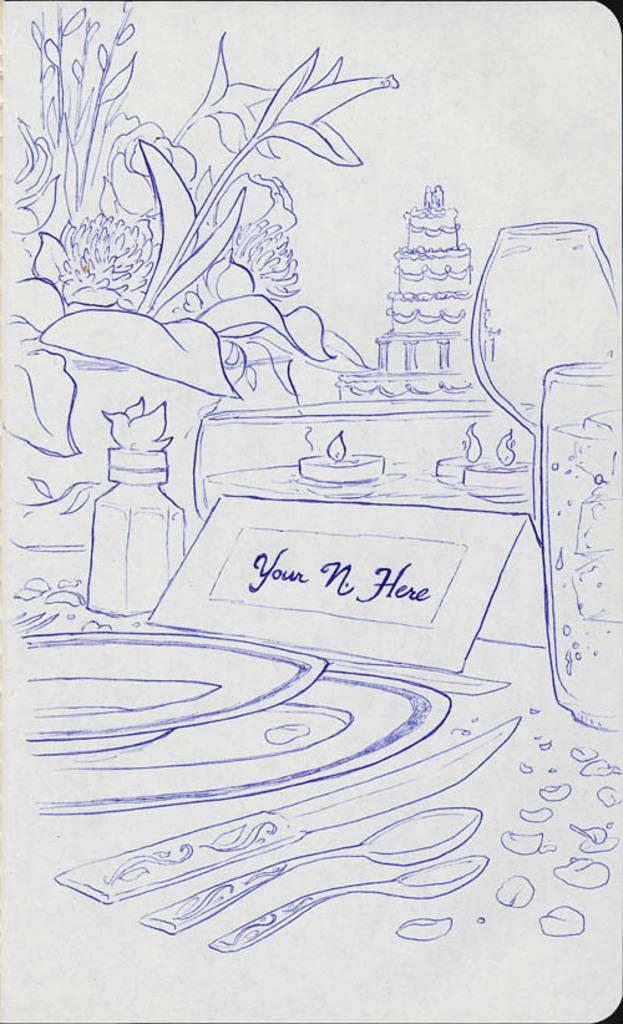What is the main subject of the drawing in the image? The main subject of the drawing in the image is a tree. What other objects are depicted in the drawing? There is a drawing of a cake, a glass, a plate, spoons, and a knife in the image. Are there any other objects drawn on the paper in the image? Yes, there are other objects drawn on the paper in the image. What type of club can be seen in the image? There is no club present in the image; it features a drawing of various objects, including a tree, cake, glass, plate, spoons, and a knife. What theory is being discussed in the image? There is no discussion or theory present in the image; it is a drawing of various objects. 